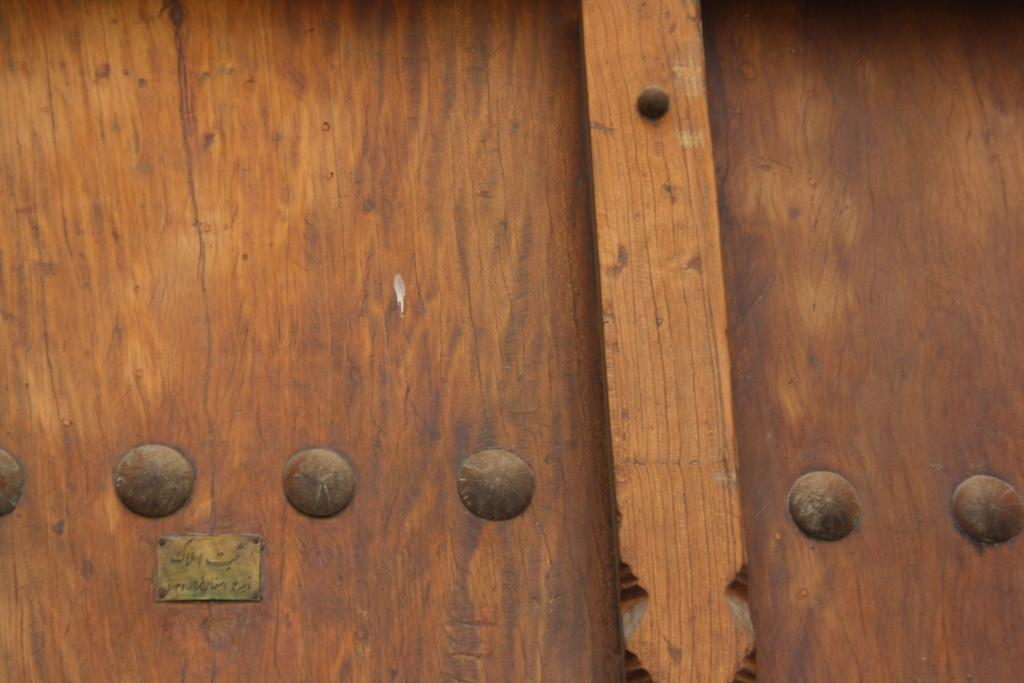What material is the main object in the image made of? The main object in the image is made of wood. Can you describe the object in more detail? The object is a wooden board. Is there a basketball being played on the wooden board in the image? No, there is no basketball or any indication of a game being played on the wooden board in the image. 